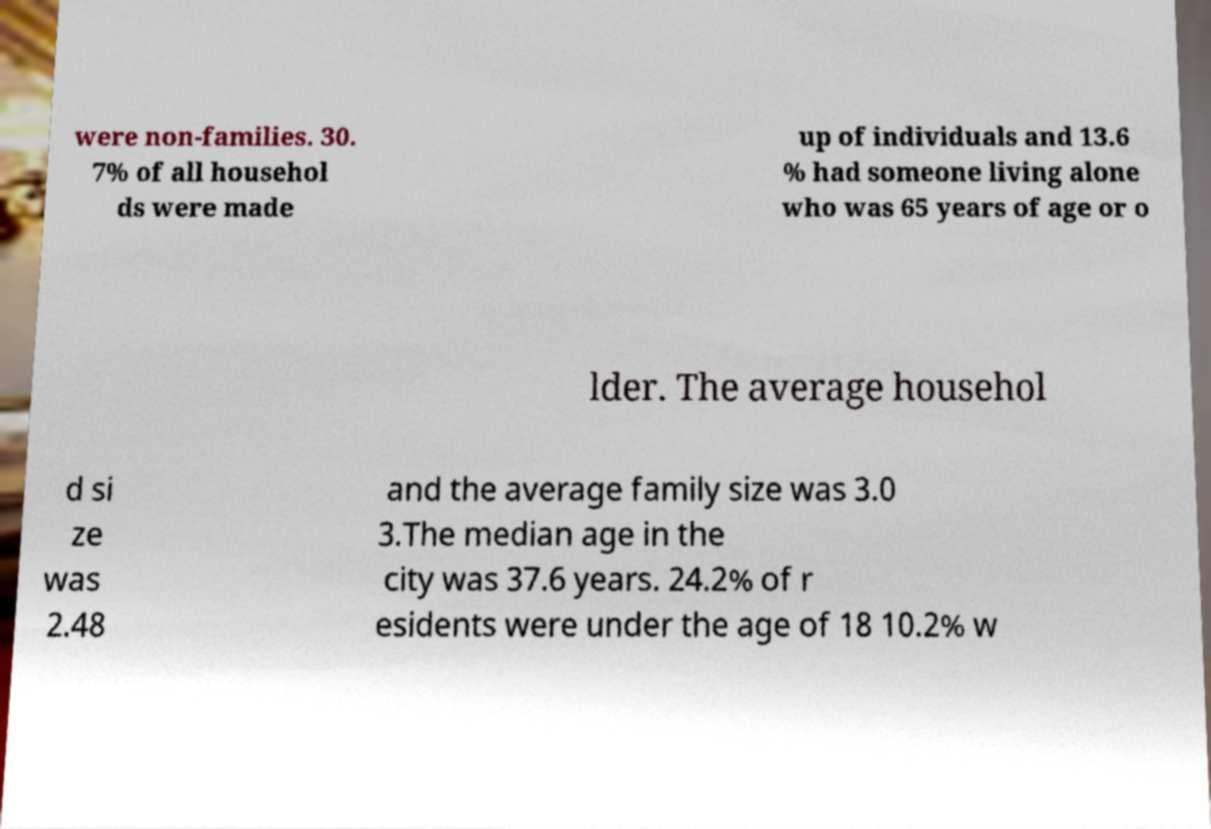Please identify and transcribe the text found in this image. were non-families. 30. 7% of all househol ds were made up of individuals and 13.6 % had someone living alone who was 65 years of age or o lder. The average househol d si ze was 2.48 and the average family size was 3.0 3.The median age in the city was 37.6 years. 24.2% of r esidents were under the age of 18 10.2% w 